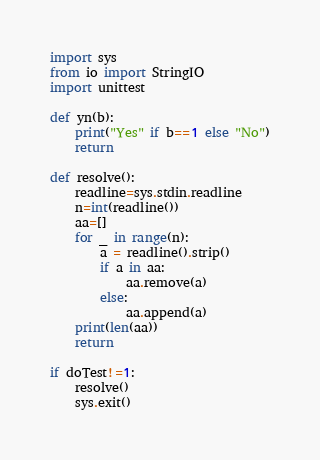Convert code to text. <code><loc_0><loc_0><loc_500><loc_500><_Python_>import sys
from io import StringIO
import unittest

def yn(b):
    print("Yes" if b==1 else "No")
    return

def resolve():
    readline=sys.stdin.readline
    n=int(readline())
    aa=[]
    for _ in range(n):
        a = readline().strip()
        if a in aa:
            aa.remove(a)
        else:
            aa.append(a)
    print(len(aa))
    return

if doTest!=1:
    resolve()
    sys.exit()</code> 